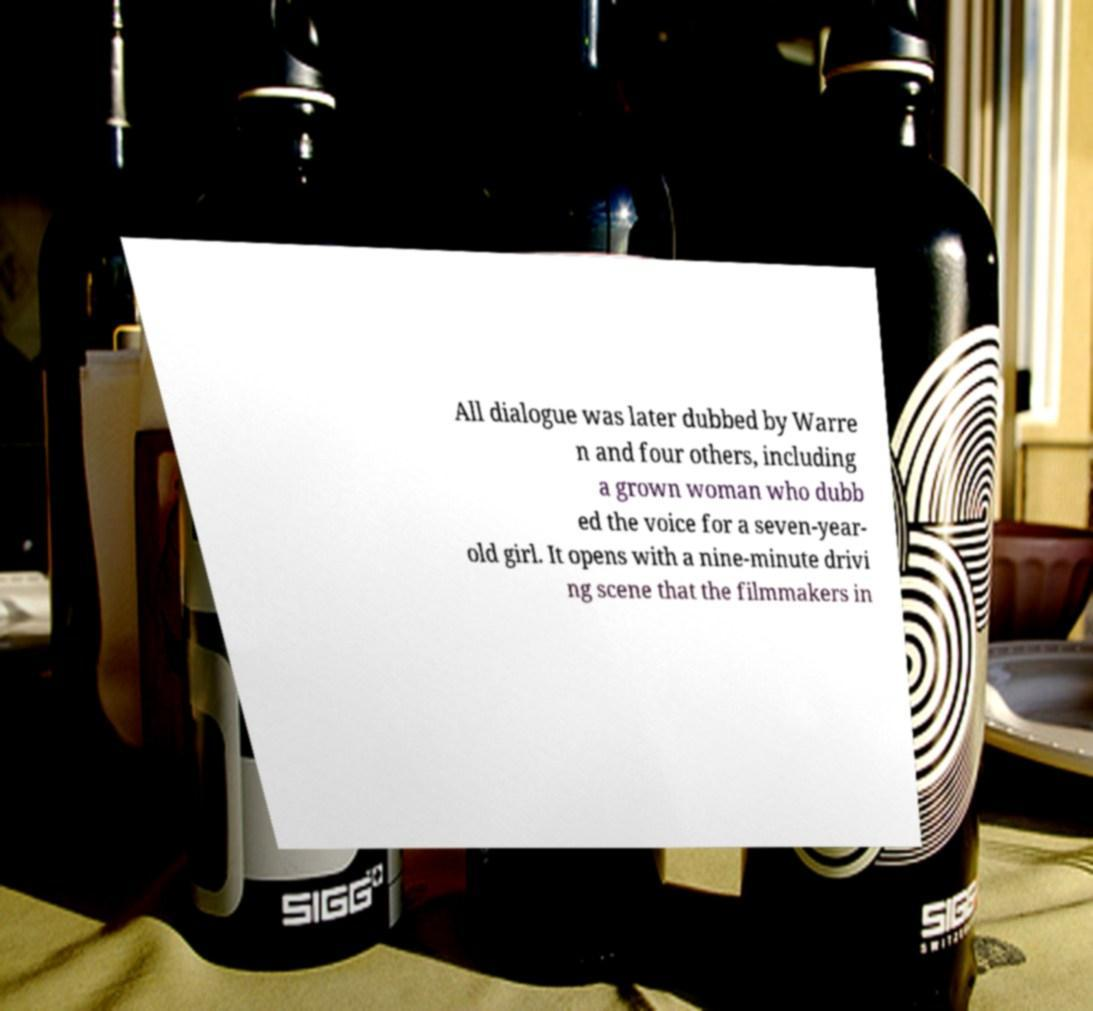Can you read and provide the text displayed in the image?This photo seems to have some interesting text. Can you extract and type it out for me? All dialogue was later dubbed by Warre n and four others, including a grown woman who dubb ed the voice for a seven-year- old girl. It opens with a nine-minute drivi ng scene that the filmmakers in 